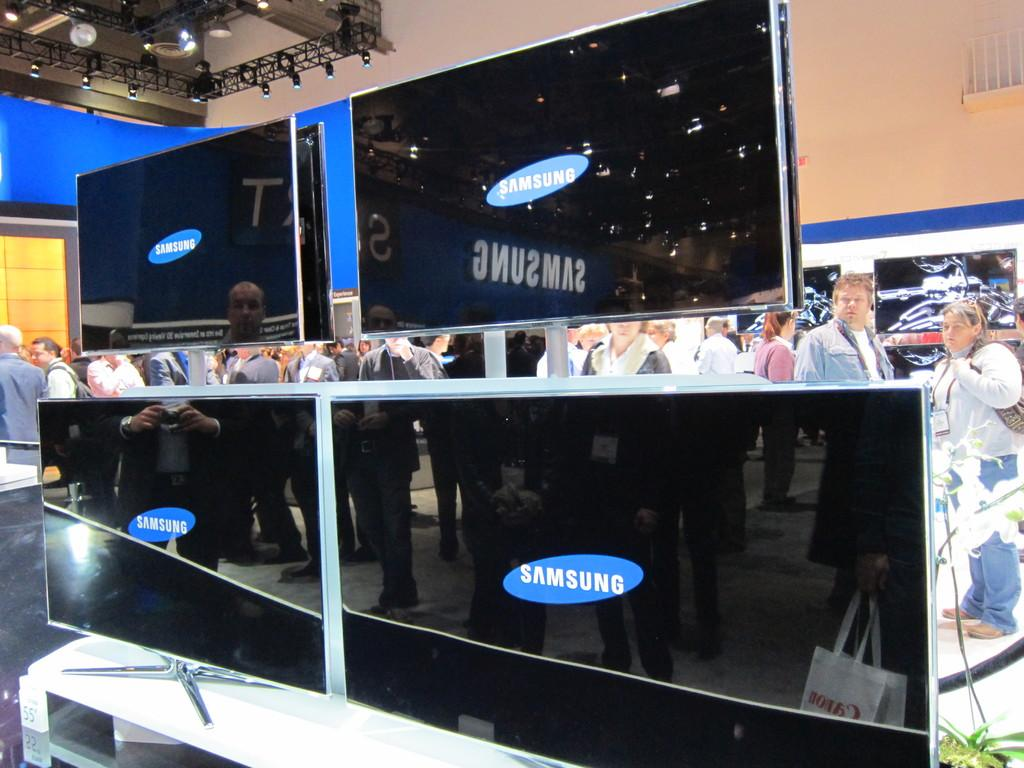<image>
Render a clear and concise summary of the photo. Four flat screen TVs are on display at a convention and say Samsung on the screens. 